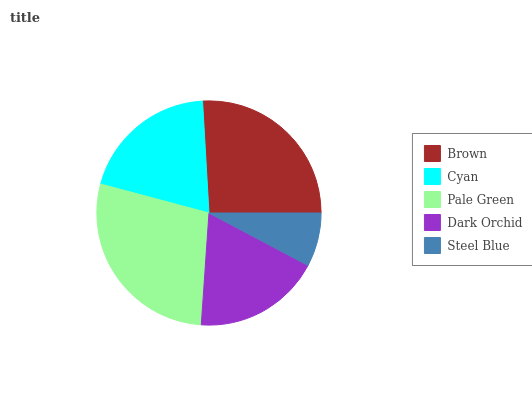Is Steel Blue the minimum?
Answer yes or no. Yes. Is Pale Green the maximum?
Answer yes or no. Yes. Is Cyan the minimum?
Answer yes or no. No. Is Cyan the maximum?
Answer yes or no. No. Is Brown greater than Cyan?
Answer yes or no. Yes. Is Cyan less than Brown?
Answer yes or no. Yes. Is Cyan greater than Brown?
Answer yes or no. No. Is Brown less than Cyan?
Answer yes or no. No. Is Cyan the high median?
Answer yes or no. Yes. Is Cyan the low median?
Answer yes or no. Yes. Is Pale Green the high median?
Answer yes or no. No. Is Pale Green the low median?
Answer yes or no. No. 